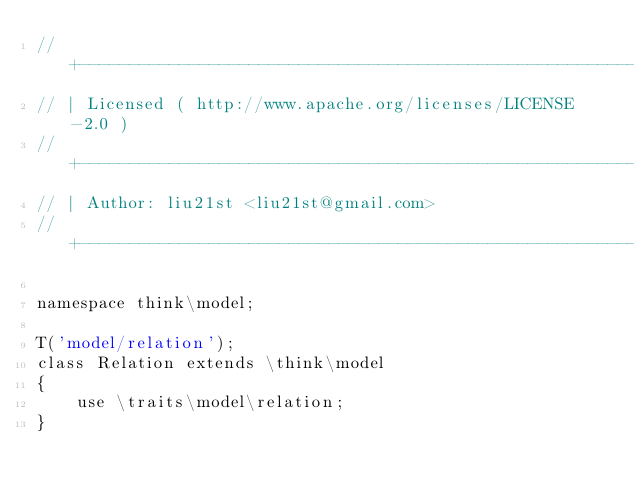Convert code to text. <code><loc_0><loc_0><loc_500><loc_500><_PHP_>// +----------------------------------------------------------------------
// | Licensed ( http://www.apache.org/licenses/LICENSE-2.0 )
// +----------------------------------------------------------------------
// | Author: liu21st <liu21st@gmail.com>
// +----------------------------------------------------------------------

namespace think\model;

T('model/relation');
class Relation extends \think\model
{
    use \traits\model\relation;
}
</code> 